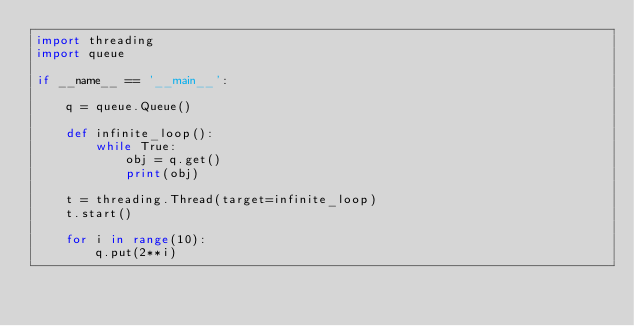<code> <loc_0><loc_0><loc_500><loc_500><_Python_>import threading
import queue

if __name__ == '__main__':

    q = queue.Queue()

    def infinite_loop():
        while True:
            obj = q.get()
            print(obj)

    t = threading.Thread(target=infinite_loop)
    t.start()

    for i in range(10):
        q.put(2**i)
</code> 